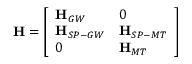Convert formula to latex. <formula><loc_0><loc_0><loc_500><loc_500>H = \left [ \begin{array} { l l } { H _ { G W } } & { 0 } \\ { H _ { S P - G W } } & { H _ { S P - M T } } \\ { 0 } & { H _ { M T } } \end{array} \right ]</formula> 